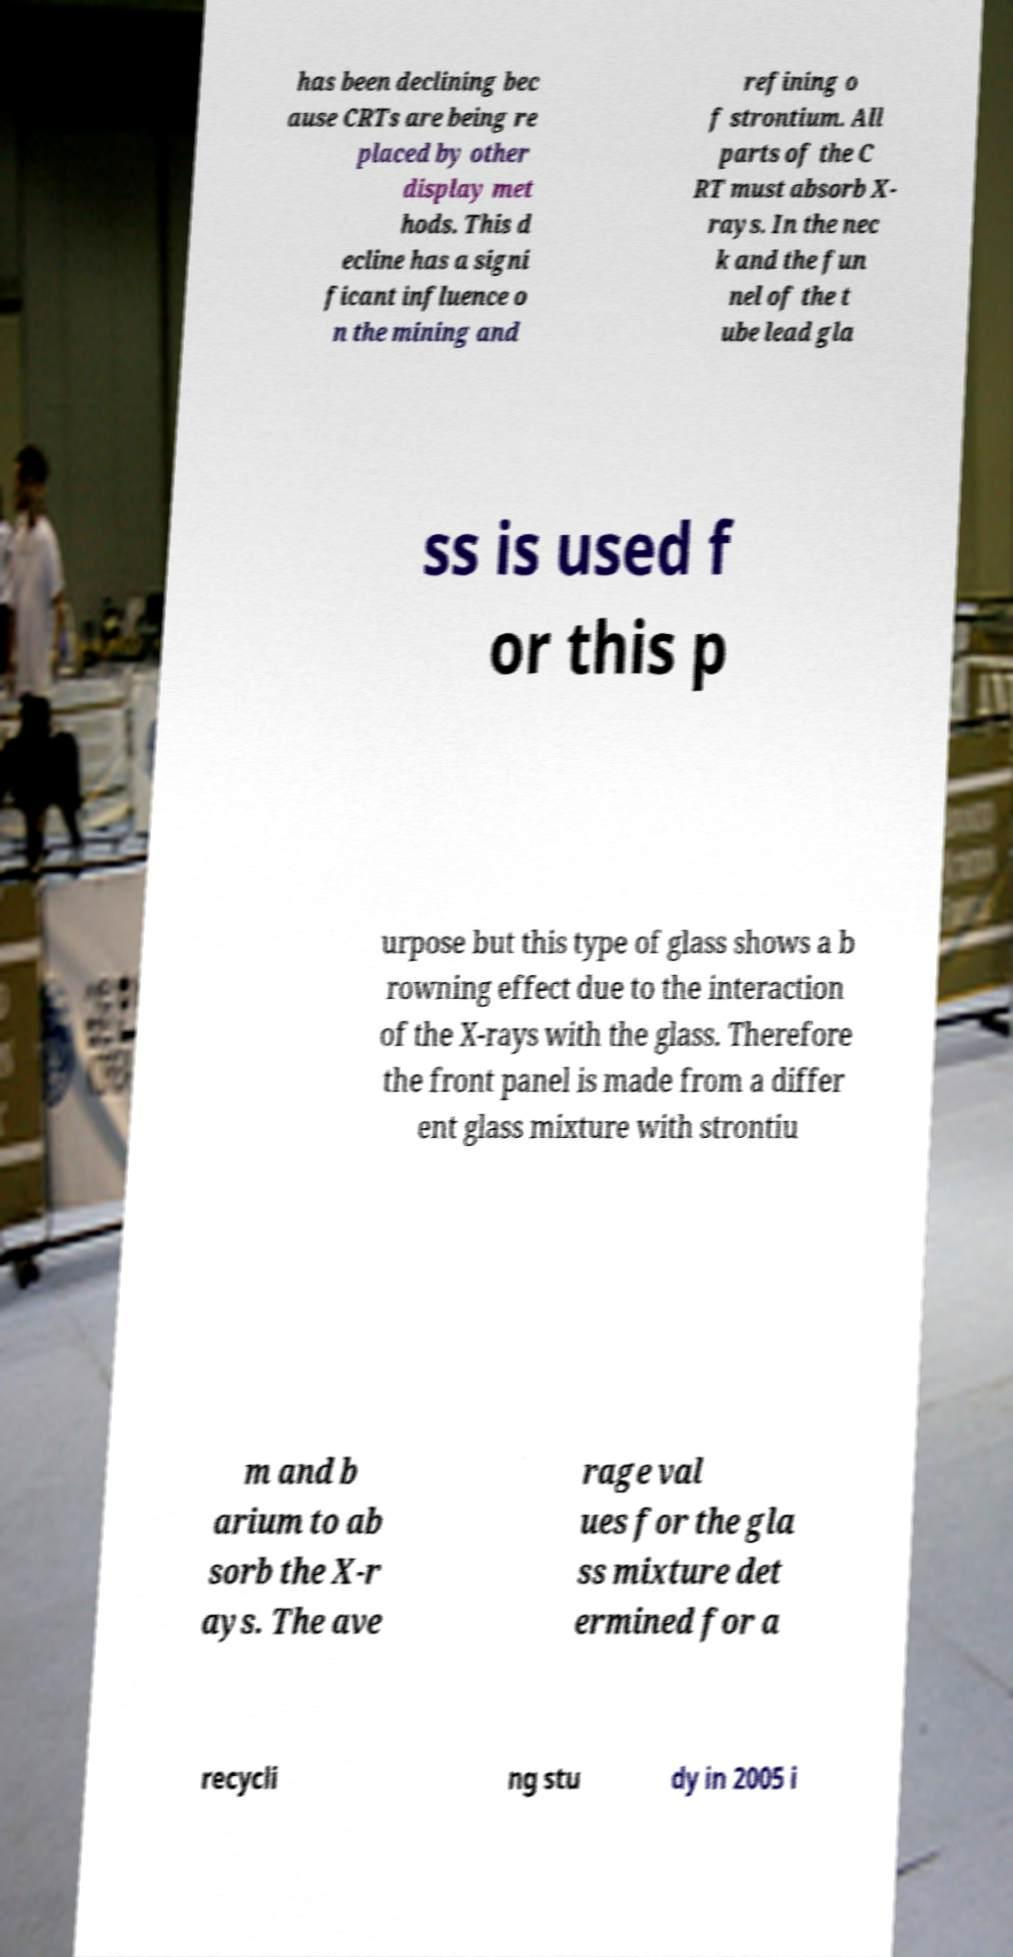There's text embedded in this image that I need extracted. Can you transcribe it verbatim? has been declining bec ause CRTs are being re placed by other display met hods. This d ecline has a signi ficant influence o n the mining and refining o f strontium. All parts of the C RT must absorb X- rays. In the nec k and the fun nel of the t ube lead gla ss is used f or this p urpose but this type of glass shows a b rowning effect due to the interaction of the X-rays with the glass. Therefore the front panel is made from a differ ent glass mixture with strontiu m and b arium to ab sorb the X-r ays. The ave rage val ues for the gla ss mixture det ermined for a recycli ng stu dy in 2005 i 